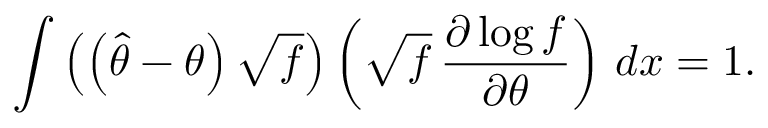Convert formula to latex. <formula><loc_0><loc_0><loc_500><loc_500>\int \left ( \left ( { \hat { \theta } } - \theta \right ) { \sqrt { f } } \right ) \left ( { \sqrt { f } } \, { \frac { \partial \log f } { \partial \theta } } \right ) \, d x = 1 .</formula> 